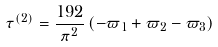Convert formula to latex. <formula><loc_0><loc_0><loc_500><loc_500>\tau ^ { ( 2 ) } = \frac { 1 9 2 } { \pi ^ { 2 } } \left ( - \varpi _ { 1 } + \varpi _ { 2 } - \varpi _ { 3 } \right )</formula> 